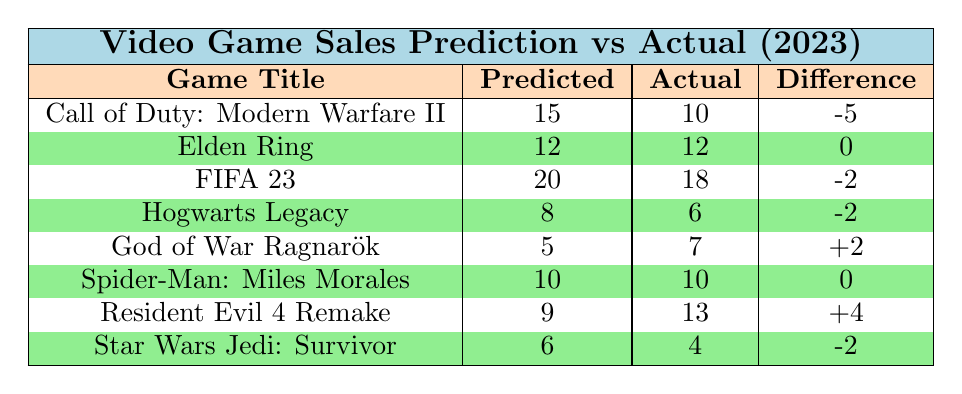What is the actual sales for "Elden Ring"? The table shows that the actual sales for the game "Elden Ring" are listed under the "Actual" column. It states that the actual sales are 12.
Answer: 12 How much did the actual sales for "Call of Duty: Modern Warfare II" exceed or fall short of the predicted sales? The predicted sales for "Call of Duty: Modern Warfare II" are 15, but the actual sales are 10. To find the difference, subtract the actual sales from the predicted sales: 15 - 10 = 5. Since the predicted sales are higher, we say it fell short by 5.
Answer: It fell short by 5 Is the predicted sales for "Resident Evil 4 Remake" greater than the actual sales? The predicted sales for "Resident Evil 4 Remake" are 9, and the actual sales are 13. Comparing these values shows that the predicted sales are not greater. Therefore, the answer is no.
Answer: No What is the total difference between predicted and actual sales across all games? To find the total difference, sum the individual differences from the table: (-5) + (0) + (-2) + (-2) + (+2) + (0) + (+4) + (-2) = -5. Thus, the total difference is -5, indicating that overall predicted sales were lower than actual sales.
Answer: -5 Which game had the highest actual sales compared to its predicted sales? First, we compare the actual versus predicted sales to find the maximum positive difference: "Resident Evil 4 Remake" has an actual sales of 13 with a predicted sales of 9, giving a difference of +4. No other game has a higher positive difference. Therefore, the answer is "Resident Evil 4 Remake."
Answer: Resident Evil 4 Remake 